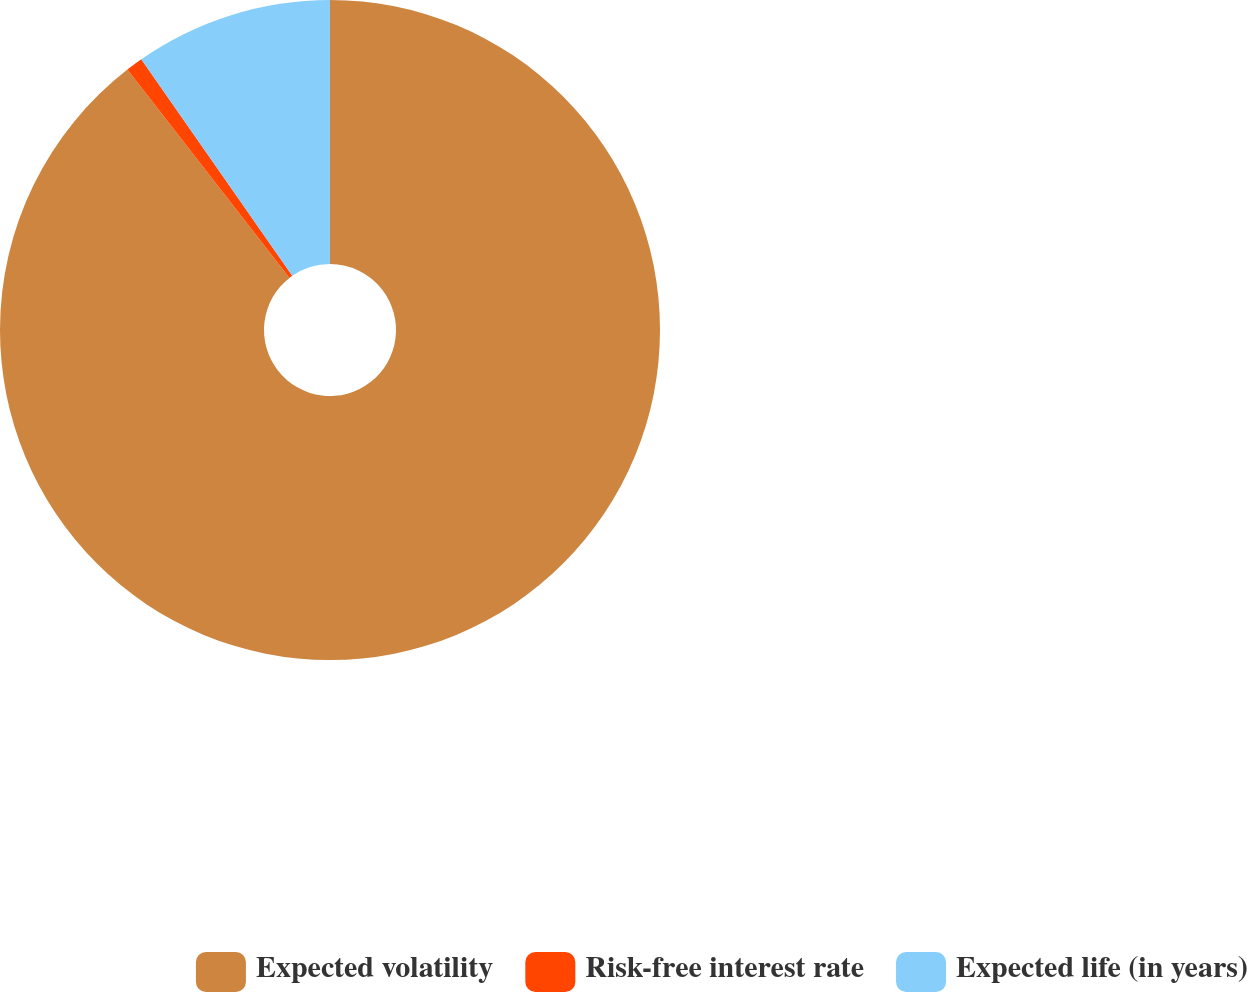<chart> <loc_0><loc_0><loc_500><loc_500><pie_chart><fcel>Expected volatility<fcel>Risk-free interest rate<fcel>Expected life (in years)<nl><fcel>89.48%<fcel>0.83%<fcel>9.69%<nl></chart> 